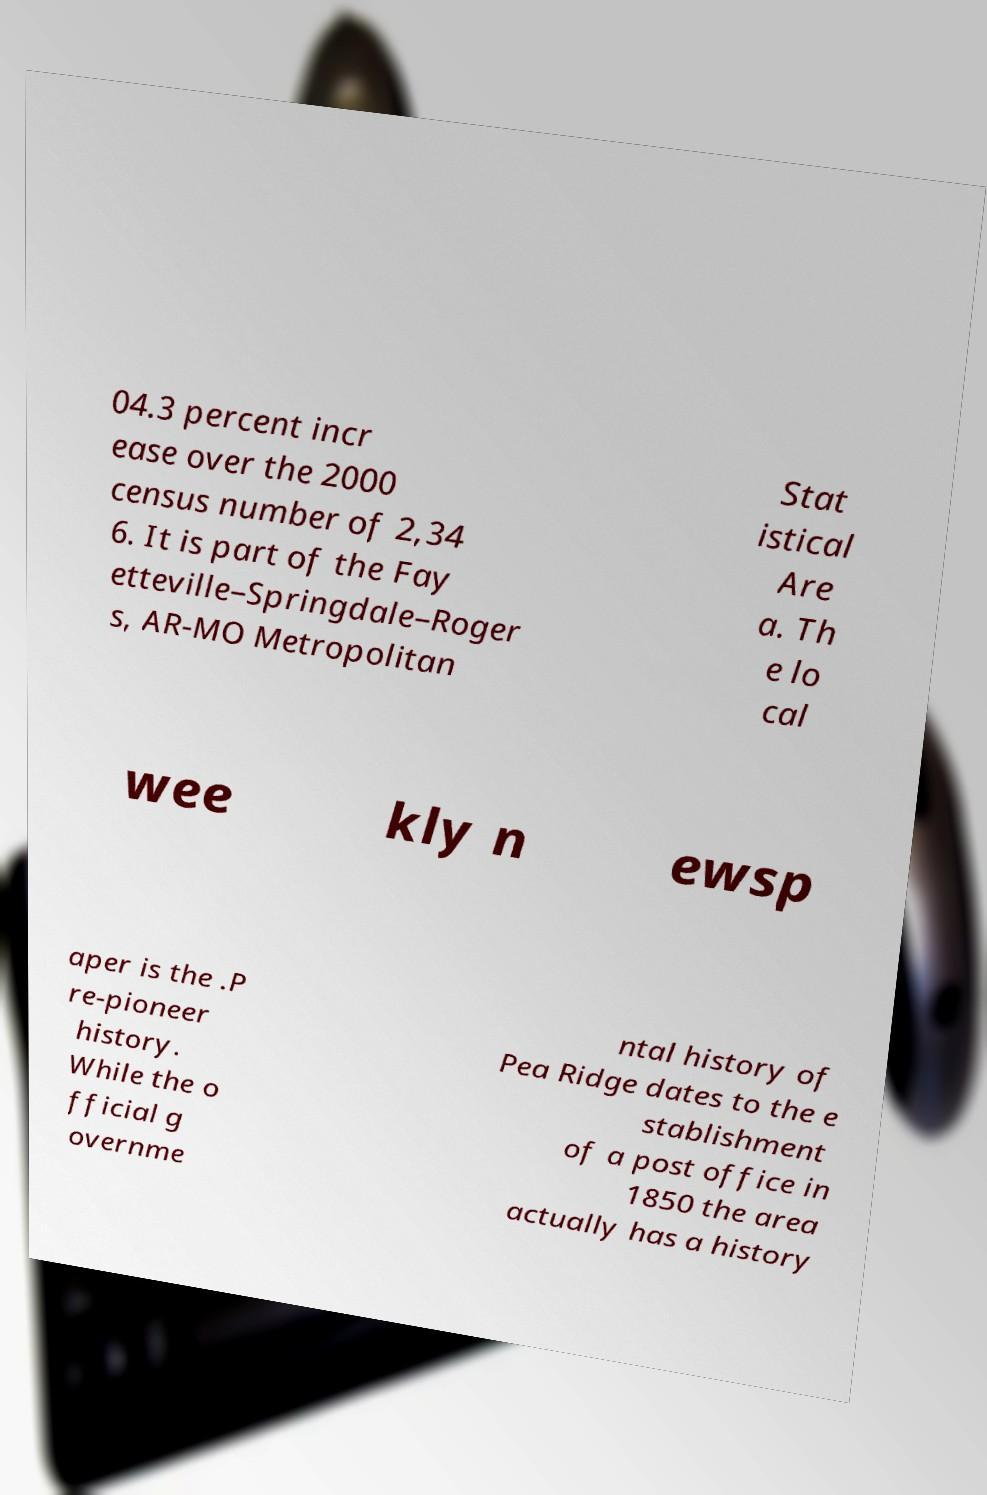Please identify and transcribe the text found in this image. 04.3 percent incr ease over the 2000 census number of 2,34 6. It is part of the Fay etteville–Springdale–Roger s, AR-MO Metropolitan Stat istical Are a. Th e lo cal wee kly n ewsp aper is the .P re-pioneer history. While the o fficial g overnme ntal history of Pea Ridge dates to the e stablishment of a post office in 1850 the area actually has a history 